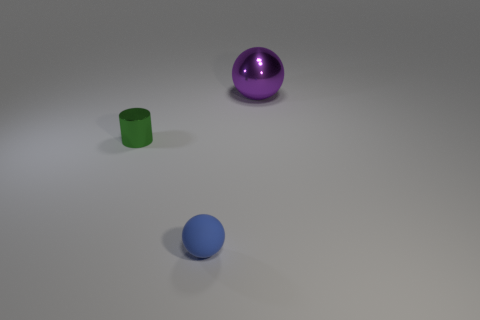Add 2 large rubber cubes. How many objects exist? 5 Subtract all cylinders. How many objects are left? 2 Subtract 0 cyan blocks. How many objects are left? 3 Subtract all large brown balls. Subtract all small matte objects. How many objects are left? 2 Add 2 tiny shiny cylinders. How many tiny shiny cylinders are left? 3 Add 3 cylinders. How many cylinders exist? 4 